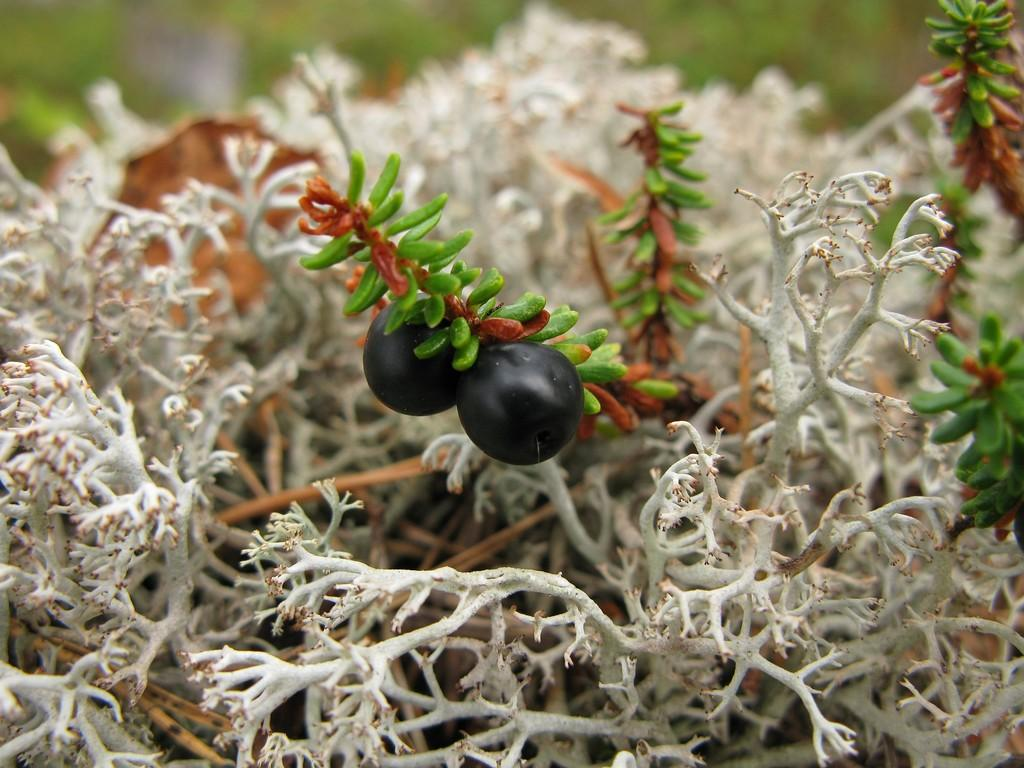What type of fruit is present in the image? There are grapes in the image. Where are the grapes located? The grapes are on a plant. Can you describe the position of the plant in the image? The plant is in the center of the image. What type of yam is being thought about by the donkey in the image? There is no donkey or yam present in the image; it features grapes on a plant. 